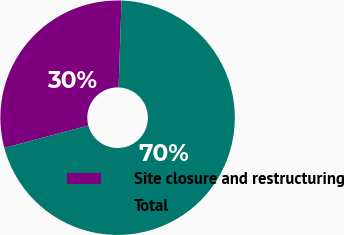Convert chart. <chart><loc_0><loc_0><loc_500><loc_500><pie_chart><fcel>Site closure and restructuring<fcel>Total<nl><fcel>29.69%<fcel>70.31%<nl></chart> 